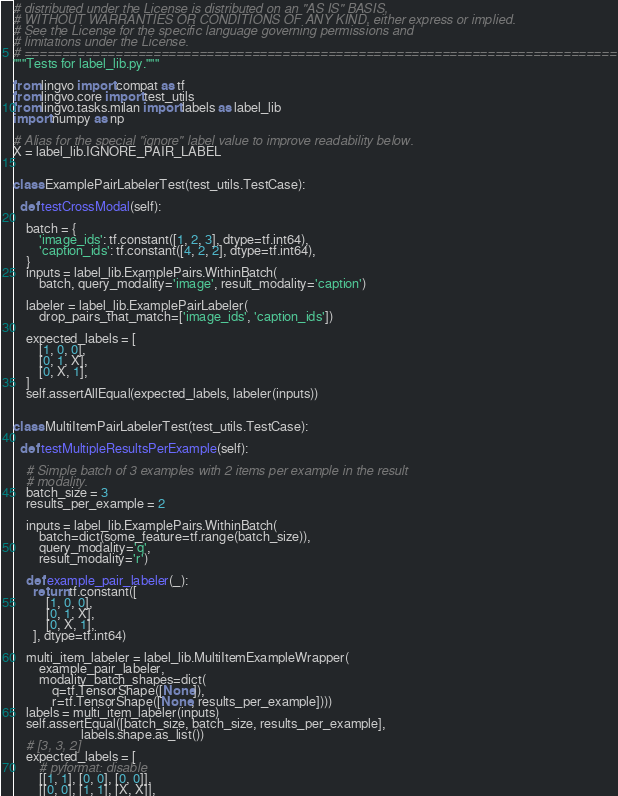<code> <loc_0><loc_0><loc_500><loc_500><_Python_># distributed under the License is distributed on an "AS IS" BASIS,
# WITHOUT WARRANTIES OR CONDITIONS OF ANY KIND, either express or implied.
# See the License for the specific language governing permissions and
# limitations under the License.
# ==============================================================================
"""Tests for label_lib.py."""

from lingvo import compat as tf
from lingvo.core import test_utils
from lingvo.tasks.milan import labels as label_lib
import numpy as np

# Alias for the special "ignore" label value to improve readability below.
X = label_lib.IGNORE_PAIR_LABEL


class ExamplePairLabelerTest(test_utils.TestCase):

  def testCrossModal(self):

    batch = {
        'image_ids': tf.constant([1, 2, 3], dtype=tf.int64),
        'caption_ids': tf.constant([4, 2, 2], dtype=tf.int64),
    }
    inputs = label_lib.ExamplePairs.WithinBatch(
        batch, query_modality='image', result_modality='caption')

    labeler = label_lib.ExamplePairLabeler(
        drop_pairs_that_match=['image_ids', 'caption_ids'])

    expected_labels = [
        [1, 0, 0],
        [0, 1, X],
        [0, X, 1],
    ]
    self.assertAllEqual(expected_labels, labeler(inputs))


class MultiItemPairLabelerTest(test_utils.TestCase):

  def testMultipleResultsPerExample(self):

    # Simple batch of 3 examples with 2 items per example in the result
    # modality.
    batch_size = 3
    results_per_example = 2

    inputs = label_lib.ExamplePairs.WithinBatch(
        batch=dict(some_feature=tf.range(batch_size)),
        query_modality='q',
        result_modality='r')

    def example_pair_labeler(_):
      return tf.constant([
          [1, 0, 0],
          [0, 1, X],
          [0, X, 1],
      ], dtype=tf.int64)

    multi_item_labeler = label_lib.MultiItemExampleWrapper(
        example_pair_labeler,
        modality_batch_shapes=dict(
            q=tf.TensorShape([None]),
            r=tf.TensorShape([None, results_per_example])))
    labels = multi_item_labeler(inputs)
    self.assertEqual([batch_size, batch_size, results_per_example],
                     labels.shape.as_list())
    # [3, 3, 2]
    expected_labels = [
        # pyformat: disable
        [[1, 1], [0, 0], [0, 0]],
        [[0, 0], [1, 1], [X, X]],</code> 